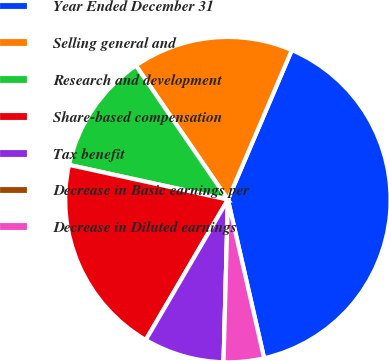<chart> <loc_0><loc_0><loc_500><loc_500><pie_chart><fcel>Year Ended December 31<fcel>Selling general and<fcel>Research and development<fcel>Share-based compensation<fcel>Tax benefit<fcel>Decrease in Basic earnings per<fcel>Decrease in Diluted earnings<nl><fcel>40.0%<fcel>16.0%<fcel>12.0%<fcel>20.0%<fcel>8.0%<fcel>0.0%<fcel>4.0%<nl></chart> 